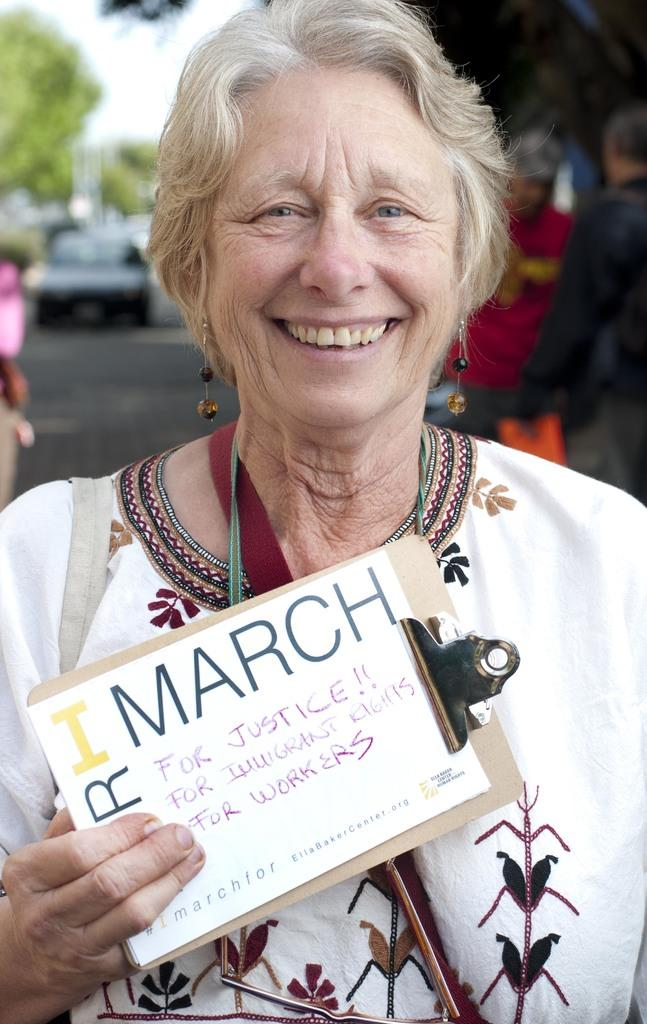Who is the main subject in the image? There is a woman in the image. What is the woman wearing? The woman is wearing a white dress. What is the woman holding in the image? The woman is holding a pad with a poster. What is the woman's facial expression? The woman is smiling. Can you describe the background of the image? There are other persons, vehicles, trees, and the sky visible in the background of the image. What type of guide is the woman holding in the image? There is no guide present in the image; the woman is holding a pad with a poster. Can you see any chickens in the image? No, there are no chickens present in the image. 